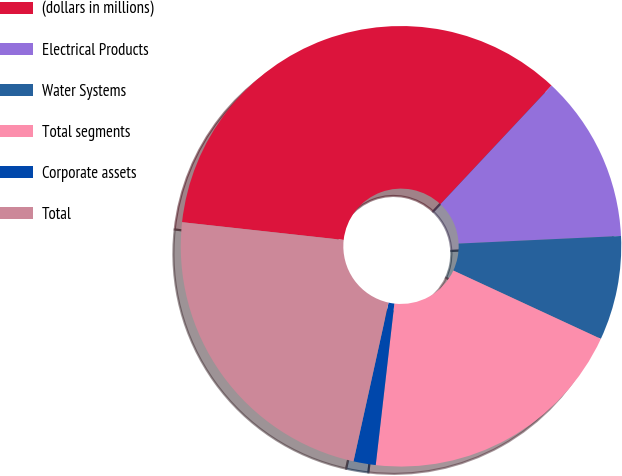Convert chart. <chart><loc_0><loc_0><loc_500><loc_500><pie_chart><fcel>(dollars in millions)<fcel>Electrical Products<fcel>Water Systems<fcel>Total segments<fcel>Corporate assets<fcel>Total<nl><fcel>35.23%<fcel>12.27%<fcel>7.65%<fcel>19.92%<fcel>1.63%<fcel>23.28%<nl></chart> 